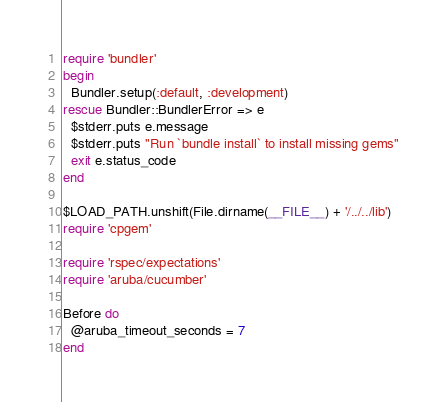<code> <loc_0><loc_0><loc_500><loc_500><_Ruby_>require 'bundler'
begin
  Bundler.setup(:default, :development)
rescue Bundler::BundlerError => e
  $stderr.puts e.message
  $stderr.puts "Run `bundle install` to install missing gems"
  exit e.status_code
end

$LOAD_PATH.unshift(File.dirname(__FILE__) + '/../../lib')
require 'cpgem'

require 'rspec/expectations'
require 'aruba/cucumber'

Before do
  @aruba_timeout_seconds = 7
end
</code> 